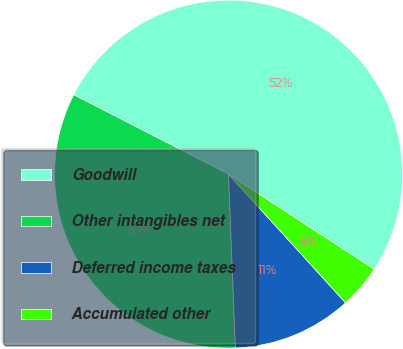Convert chart. <chart><loc_0><loc_0><loc_500><loc_500><pie_chart><fcel>Goodwill<fcel>Other intangibles net<fcel>Deferred income taxes<fcel>Accumulated other<nl><fcel>51.64%<fcel>33.18%<fcel>11.12%<fcel>4.05%<nl></chart> 